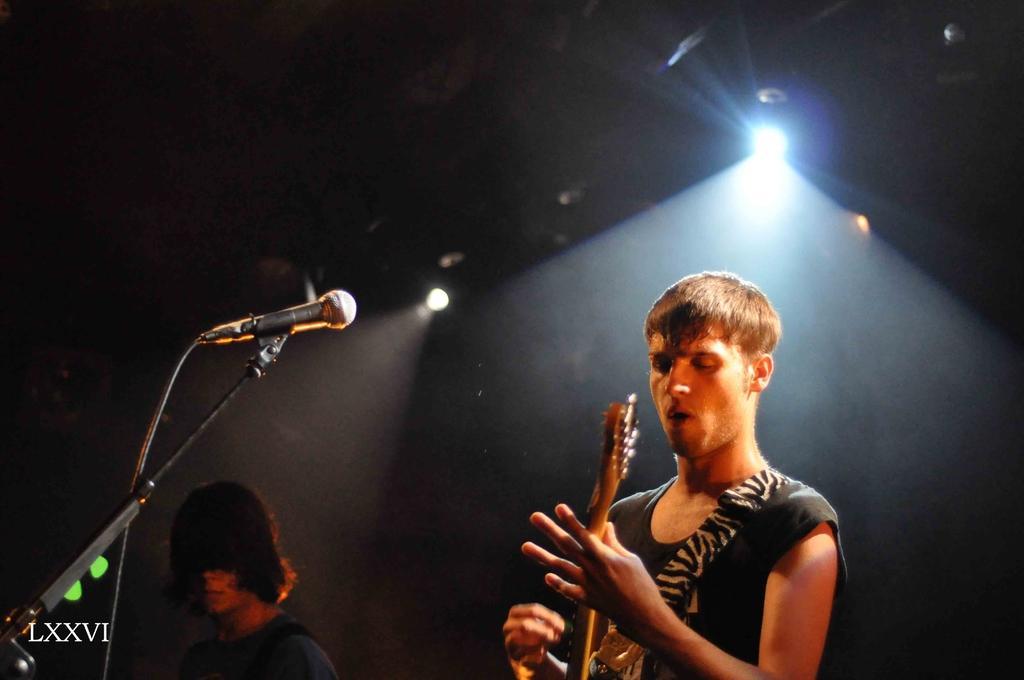How would you summarize this image in a sentence or two? This picture is clicked in a musical concert. The man in the right corner of the picture wearing black t-shirt is holding guitar in his hands and playing it. I think he is also singing. The man on the left, is wearing spectacles. On the left bottom of the picture, we see a microphone. 